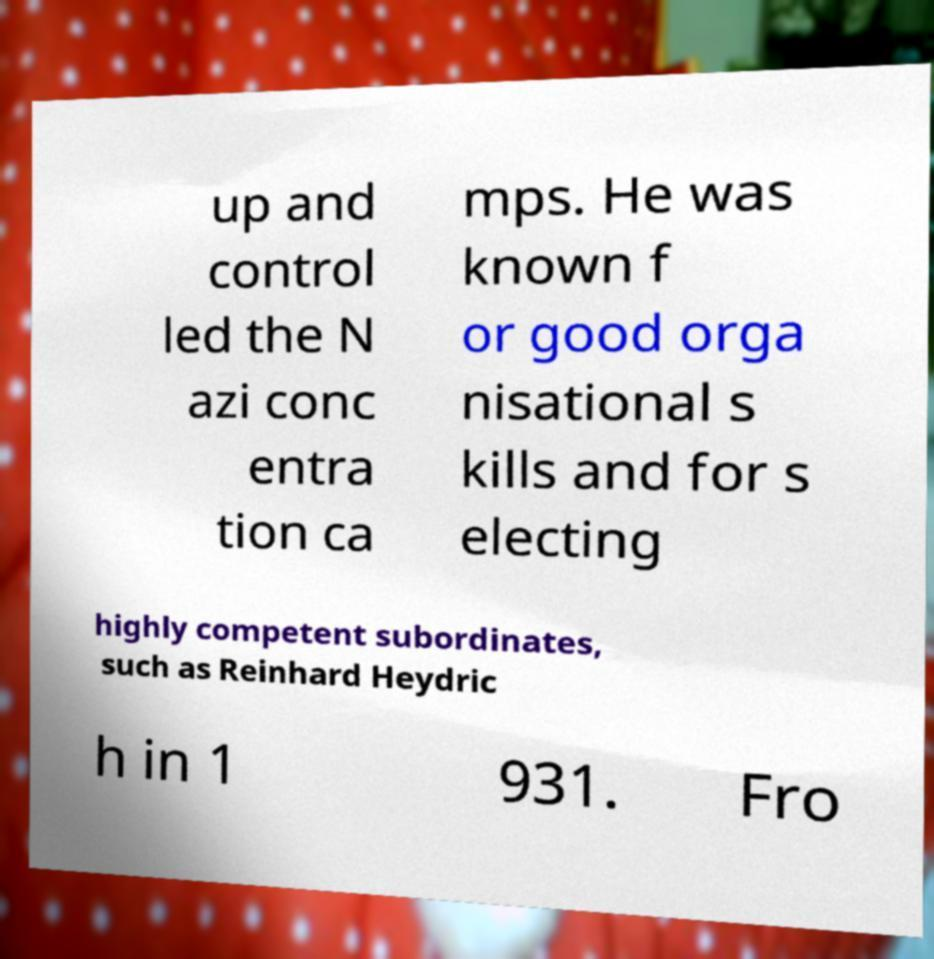What messages or text are displayed in this image? I need them in a readable, typed format. up and control led the N azi conc entra tion ca mps. He was known f or good orga nisational s kills and for s electing highly competent subordinates, such as Reinhard Heydric h in 1 931. Fro 